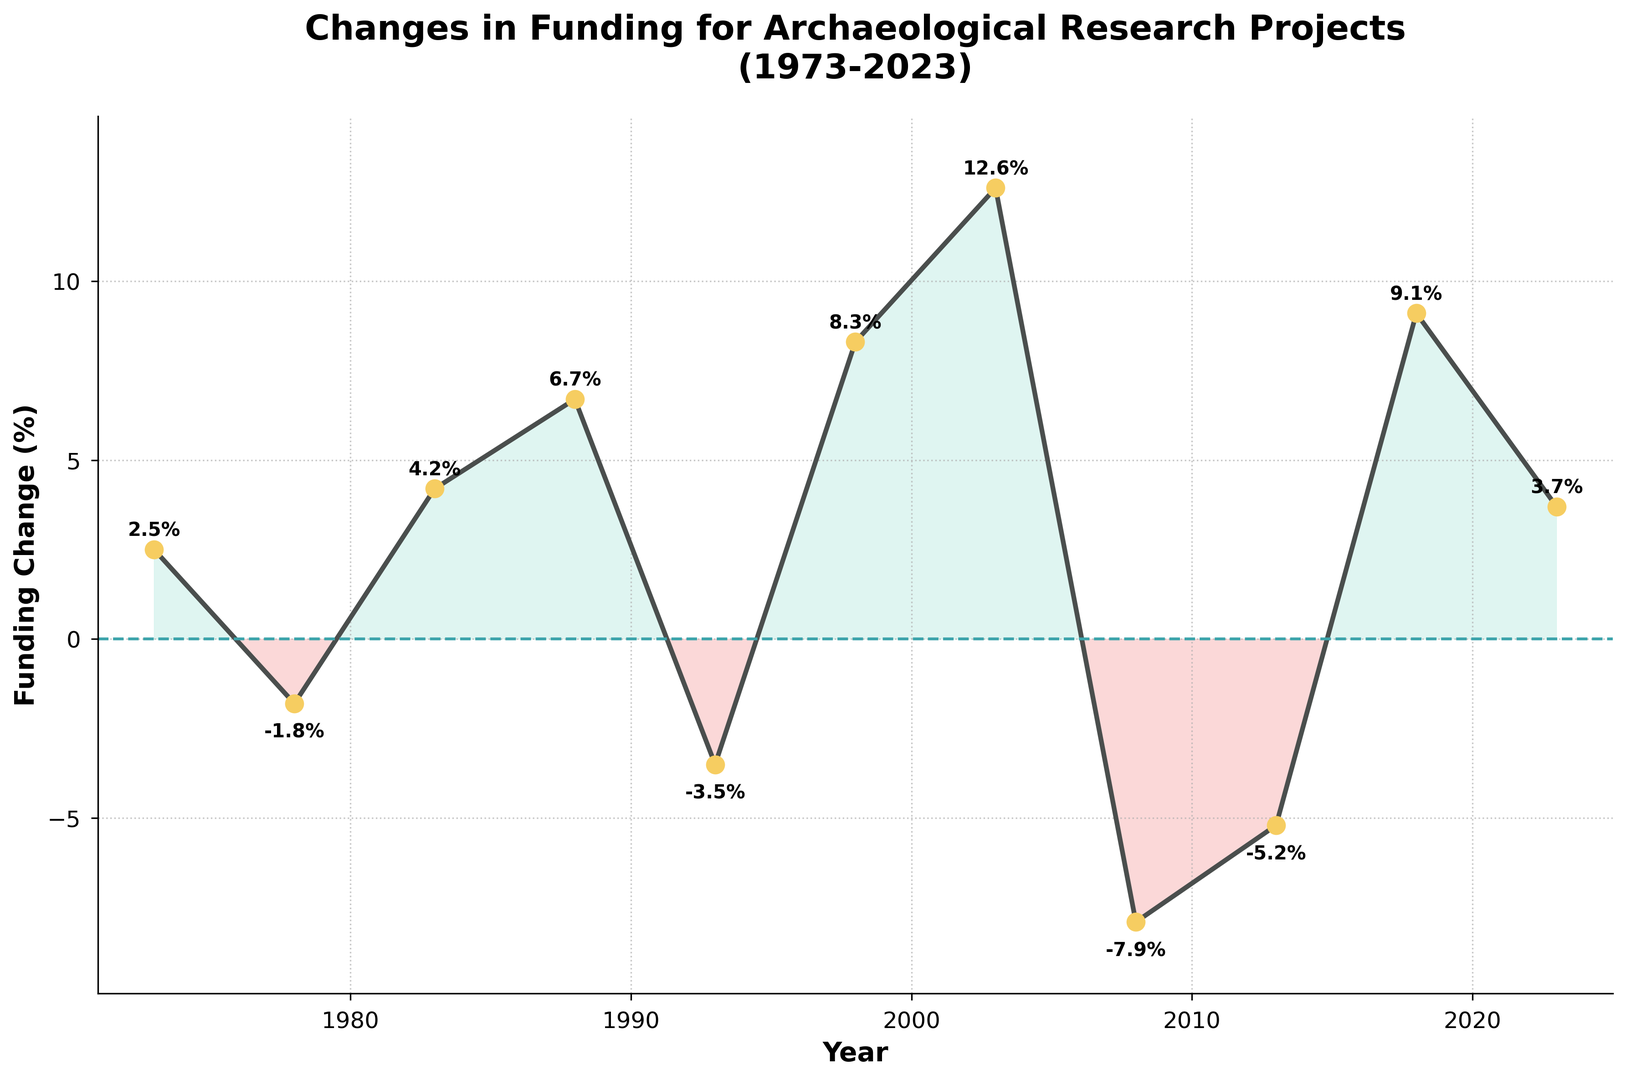What year saw the highest increase in funding for archaeological research projects? By observing the plot, look for the year with the highest positive value above the zero line. The highest positive point is in 2003 with a funding change of 12.6%.
Answer: 2003 Which years experienced a decrease in funding? Identify the points below the zero line on the plot and read the corresponding years. The years with negative funding changes are 1978, 1993, 2008, and 2013.
Answer: 1978, 1993, 2008, 2013 What is the difference in funding change between the highest and lowest points? Locate the highest and lowest points on the plot. The highest point is 12.6% in 2003, and the lowest point is -7.9% in 2008. Calculate the difference: 12.6% - (-7.9%) = 20.5%.
Answer: 20.5% During which decade did funding change the most drastically? Compare the magnitude of changes within each decade by observing the plot visually. The 2000s had changes of 12.6% in 2003 and -7.9% in 2008, providing a substantial contrast.
Answer: 2000s What overall trend can be noticed from 1973 to 2023? Consider the general direction of the funding changes across the years on the plot. Although there are fluctuations, an overall upward trend is noticeable from the gradual increase in positive values.
Answer: Upward trend What was the funding change in 1998 compared to 1983? Observe the plot and note the values for 1998 and 1983. In 1998, it was 8.3%, and in 1983 it was 4.2%.
Answer: 8.3% vs. 4.2% How many years had a funding change of 5% or more? Look at the plot and count the number of points with funding changes of 5% or greater. The years meeting this criterion are 1988 (6.7%), 1998 (8.3%), 2003 (12.6%), and 2018 (9.1%), totaling 4 years.
Answer: 4 What color indicates years with a reduction in funding? Observe the shading color used for negative values below the zero line. Declines are represented by a red (or similar) color fill.
Answer: Red Which year had a better funding increase: 2018 or 2023? Compare the funding changes for 2018 and 2023 on the plot. In 2018, it was 9.1%, and in 2023 it was 3.7%.
Answer: 2018 When did the funding change first become negative? Identify the first point below the zero line by following the chronological order on the plot. The first negative funding change appears in 1978 with -1.8%.
Answer: 1978 